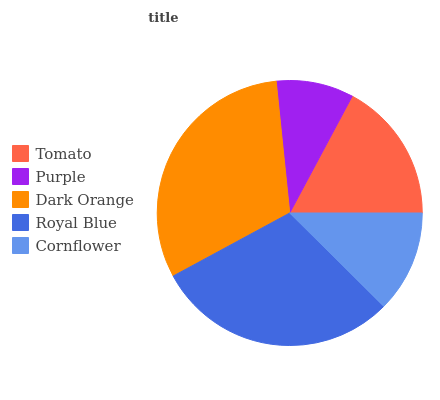Is Purple the minimum?
Answer yes or no. Yes. Is Dark Orange the maximum?
Answer yes or no. Yes. Is Dark Orange the minimum?
Answer yes or no. No. Is Purple the maximum?
Answer yes or no. No. Is Dark Orange greater than Purple?
Answer yes or no. Yes. Is Purple less than Dark Orange?
Answer yes or no. Yes. Is Purple greater than Dark Orange?
Answer yes or no. No. Is Dark Orange less than Purple?
Answer yes or no. No. Is Tomato the high median?
Answer yes or no. Yes. Is Tomato the low median?
Answer yes or no. Yes. Is Royal Blue the high median?
Answer yes or no. No. Is Cornflower the low median?
Answer yes or no. No. 